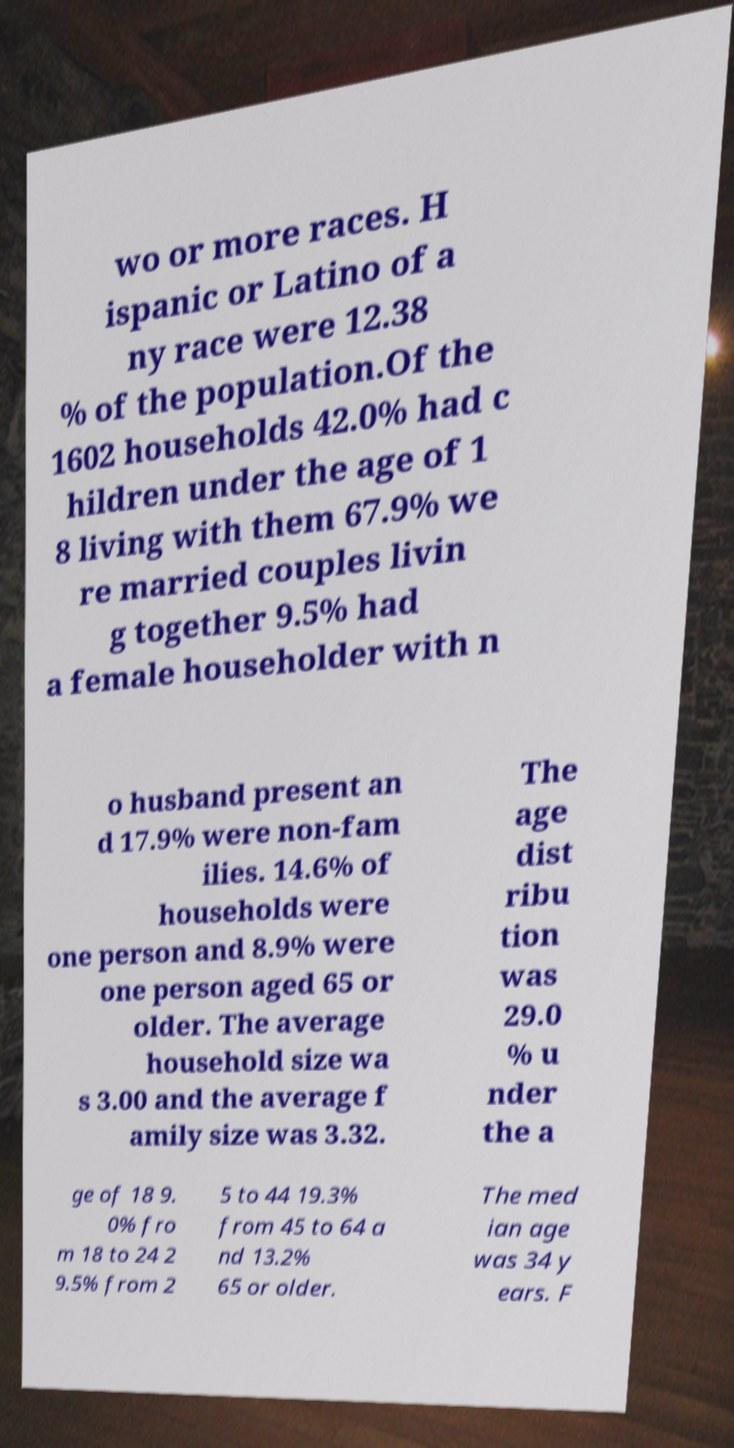For documentation purposes, I need the text within this image transcribed. Could you provide that? wo or more races. H ispanic or Latino of a ny race were 12.38 % of the population.Of the 1602 households 42.0% had c hildren under the age of 1 8 living with them 67.9% we re married couples livin g together 9.5% had a female householder with n o husband present an d 17.9% were non-fam ilies. 14.6% of households were one person and 8.9% were one person aged 65 or older. The average household size wa s 3.00 and the average f amily size was 3.32. The age dist ribu tion was 29.0 % u nder the a ge of 18 9. 0% fro m 18 to 24 2 9.5% from 2 5 to 44 19.3% from 45 to 64 a nd 13.2% 65 or older. The med ian age was 34 y ears. F 